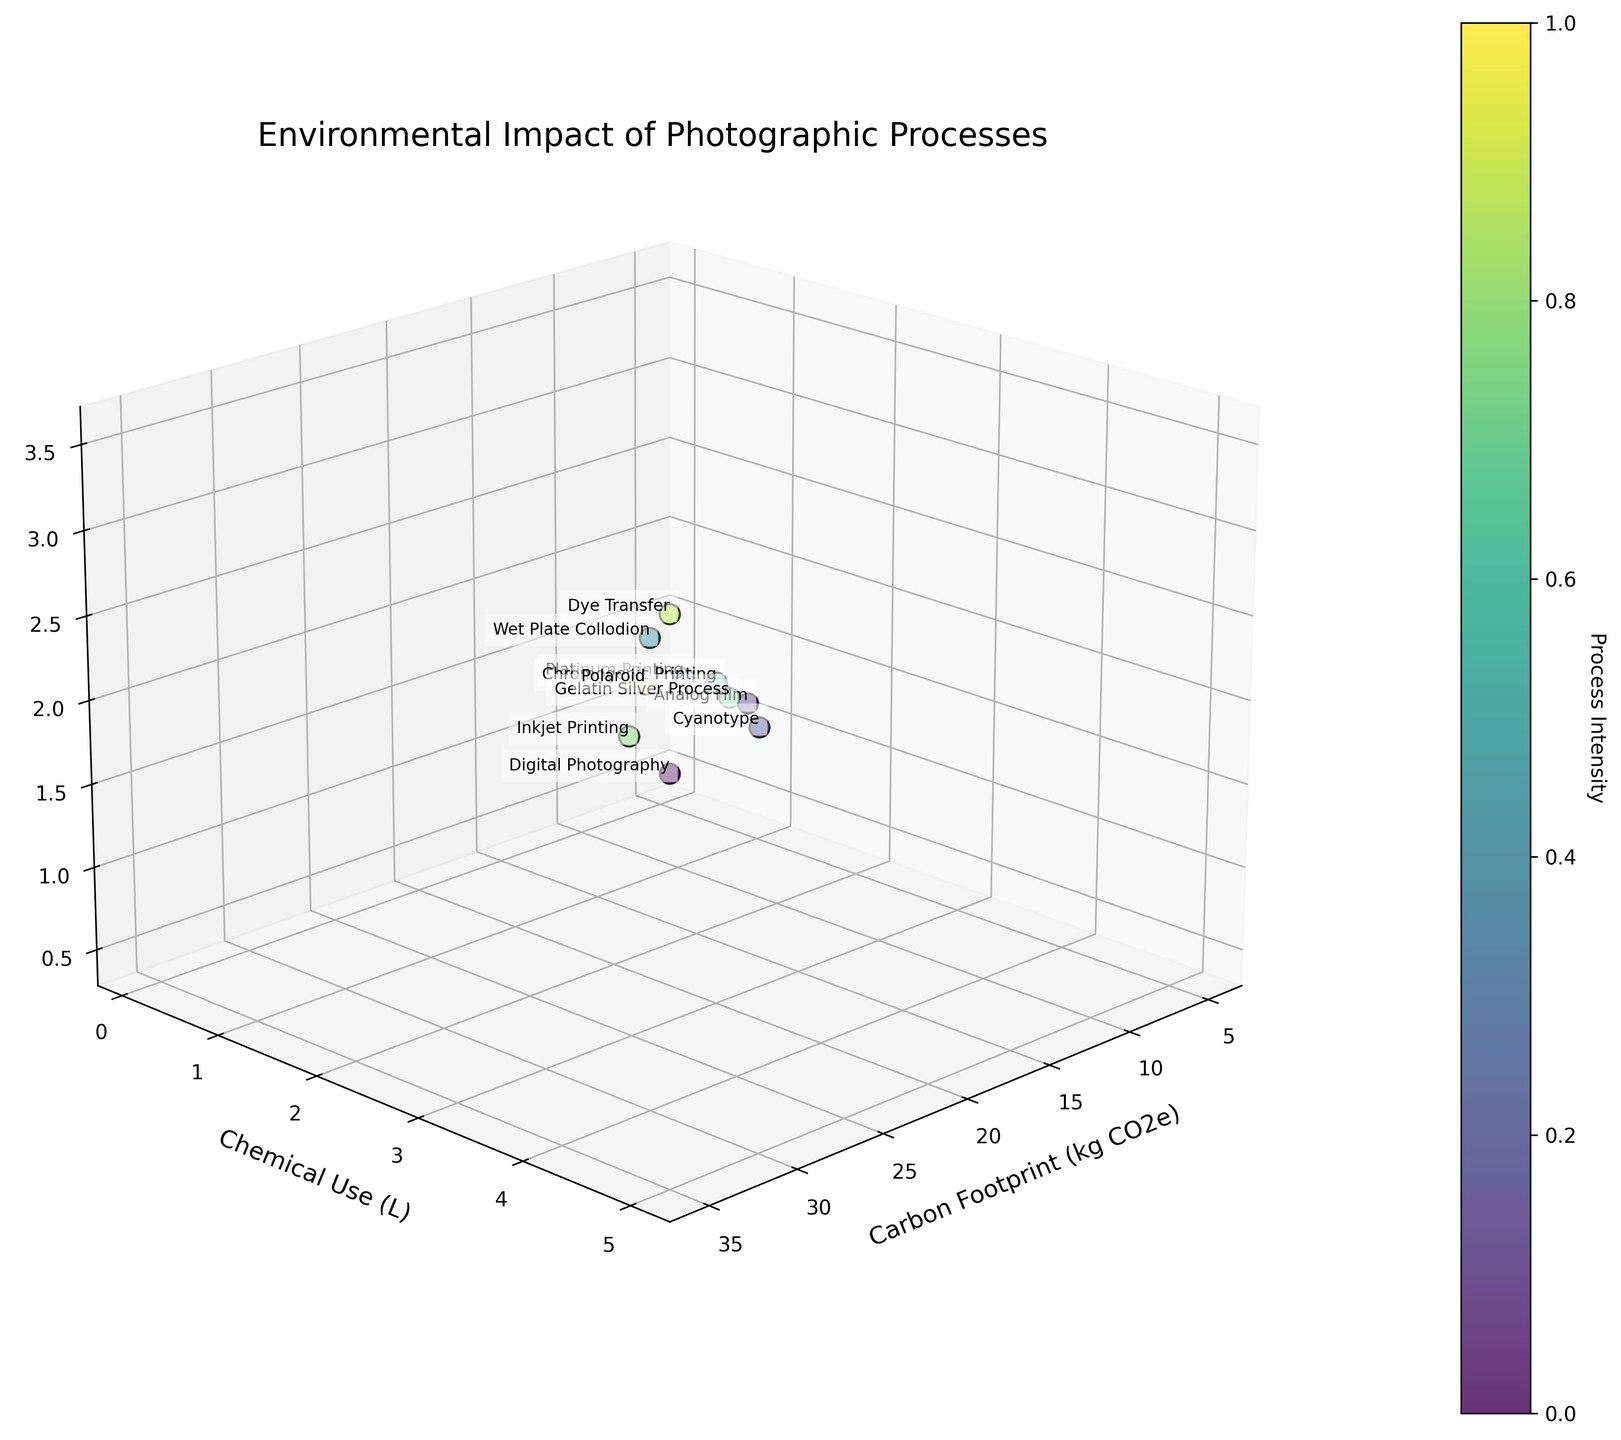What is the title of the 3D plot? The title is clearly written at the top of the plot, stating the focus of the data.
Answer: Environmental Impact of Photographic Processes How many different photographic processes are shown in the plot? Count the number of distinct points labeled with photographic process names in the 3D plot.
Answer: 10 What is the chemical use of the Gelatin Silver Process? Look at the point labeled "Gelatin Silver Process" and check its position on the Chemical Use axis.
Answer: 2.8 L Which photographic process has the highest waste production? Identify the point with the highest value on the Waste Production axis and check its label.
Answer: Dye Transfer Which photographic process has the lowest carbon footprint? Identify the point with the lowest value on the Carbon Footprint axis and check its label.
Answer: Digital Photography How does the chemical use of Cyanotype compare with Polaroid? Compare the positions of Cyanotype and Polaroid on the Chemical Use axis. Cyanotype is at 1.5L while Polaroid is at 1.0L.
Answer: Cyanotype uses more chemicals than Polaroid What is the approximate position of Chromogenic Printing in terms of carbon footprint and waste production? Find the point labeled "Chromogenic Printing" and approximate its coordinates along the Carbon Footprint and Waste Production axes.
Answer: Approximately 20 kg CO2e and 2.2 kg waste What is the average waste production of Digital Photography, Inkjet Printing, and Polaroid? Waste production of Digital Photography (0.5 kg), Inkjet Printing (1.0 kg), and Polaroid (1.5 kg). Sum = 0.5 + 1.0 + 1.5 = 3.0 kg, then divide by 3: 3.0 / 3
Answer: 1.0 kg Which process has a higher carbon footprint: Cyanotype or Platinum Printing? Compare the positions of Cyanotype and Platinum Printing on the Carbon Footprint axis. Cyanotype is at 8 kg CO2e and Platinum Printing is at 25 kg CO2e.
Answer: Platinum Printing What’s the difference in chemical use between Wet Plate Collodion and Analog Film? Chemical use of Wet Plate Collodion: 4.0 L, Analog Film: 2.5 L. Difference: 4.0 - 2.5
Answer: 1.5 L 